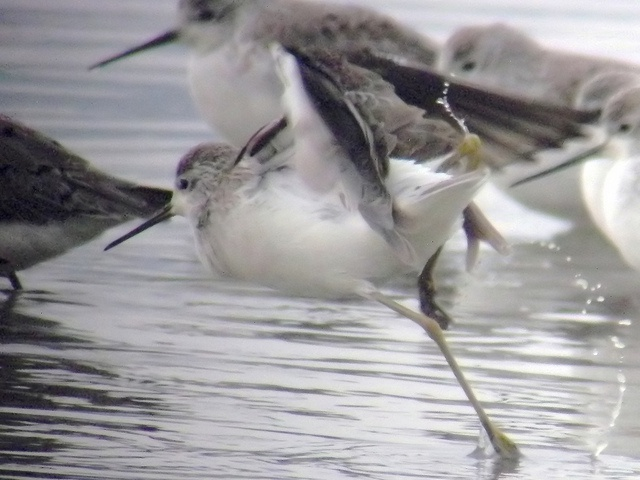Describe the objects in this image and their specific colors. I can see bird in gray, darkgray, black, and lightgray tones, bird in gray, darkgray, and black tones, bird in gray, darkgray, and lightgray tones, bird in gray and black tones, and bird in gray, lightgray, and darkgray tones in this image. 